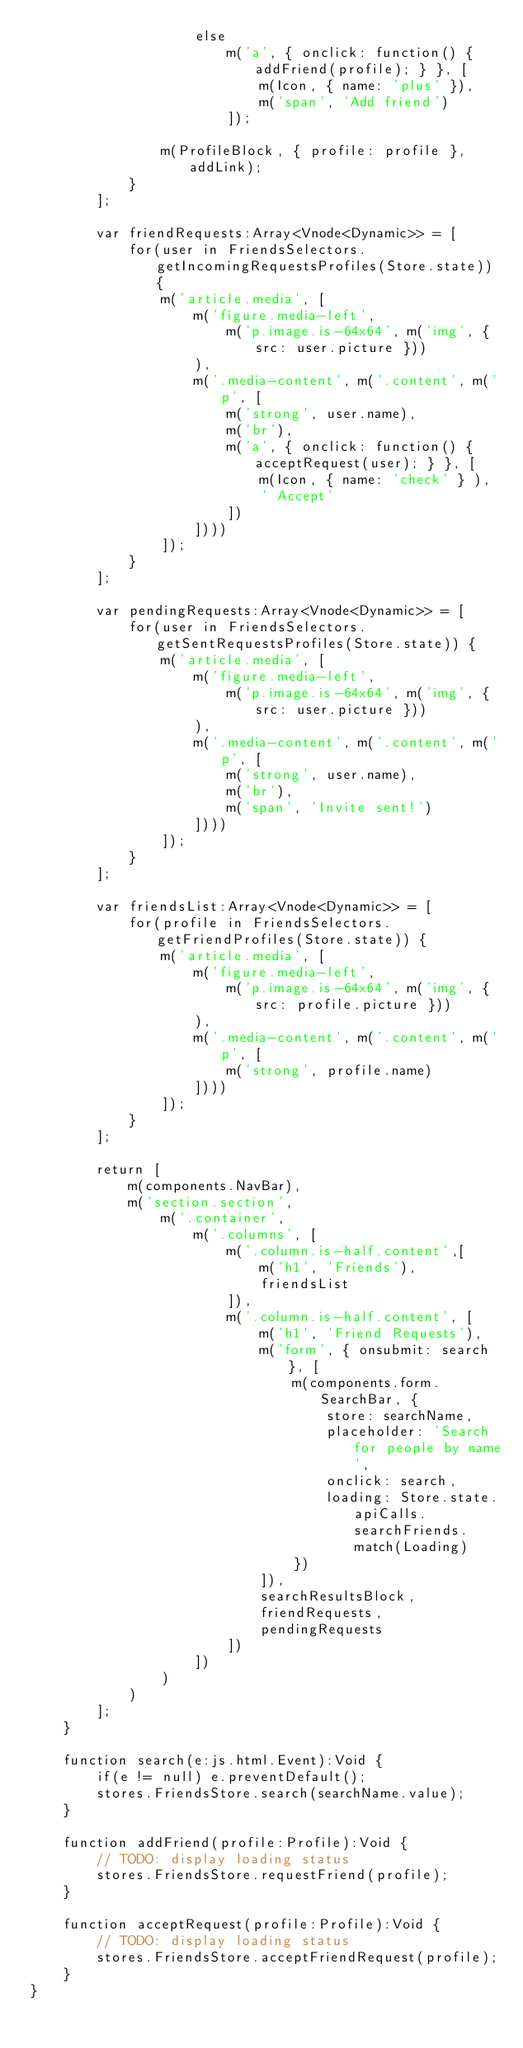Convert code to text. <code><loc_0><loc_0><loc_500><loc_500><_Haxe_>                    else
                        m('a', { onclick: function() { addFriend(profile); } }, [
                            m(Icon, { name: 'plus' }),
                            m('span', 'Add friend')
                        ]);

                m(ProfileBlock, { profile: profile }, addLink);
            }
        ];

        var friendRequests:Array<Vnode<Dynamic>> = [
            for(user in FriendsSelectors.getIncomingRequestsProfiles(Store.state)) {
                m('article.media', [
                    m('figure.media-left',
                        m('p.image.is-64x64', m('img', { src: user.picture }))
                    ),
                    m('.media-content', m('.content', m('p', [
                        m('strong', user.name),
                        m('br'),
                        m('a', { onclick: function() { acceptRequest(user); } }, [
                            m(Icon, { name: 'check' } ),
                            ' Accept'
                        ])
                    ])))
                ]);
            }
        ];

        var pendingRequests:Array<Vnode<Dynamic>> = [
            for(user in FriendsSelectors.getSentRequestsProfiles(Store.state)) {
                m('article.media', [
                    m('figure.media-left',
                        m('p.image.is-64x64', m('img', { src: user.picture }))
                    ),
                    m('.media-content', m('.content', m('p', [
                        m('strong', user.name),
                        m('br'),
                        m('span', 'Invite sent!')
                    ])))
                ]);
            }
        ];

        var friendsList:Array<Vnode<Dynamic>> = [
            for(profile in FriendsSelectors.getFriendProfiles(Store.state)) {
                m('article.media', [
                    m('figure.media-left',
                        m('p.image.is-64x64', m('img', { src: profile.picture }))
                    ),
                    m('.media-content', m('.content', m('p', [
                        m('strong', profile.name)
                    ])))
                ]);
            }
        ];

        return [
            m(components.NavBar),
            m('section.section',
                m('.container',
                    m('.columns', [
                        m('.column.is-half.content',[
                            m('h1', 'Friends'),
                            friendsList
                        ]),
                        m('.column.is-half.content', [
                            m('h1', 'Friend Requests'),
                            m('form', { onsubmit: search }, [
                                m(components.form.SearchBar, {
                                    store: searchName,
                                    placeholder: 'Search for people by name',
                                    onclick: search,
                                    loading: Store.state.apiCalls.searchFriends.match(Loading)
                                })
                            ]),
                            searchResultsBlock,
                            friendRequests,
                            pendingRequests
                        ])
                    ])
                )
            )
        ];
    }

    function search(e:js.html.Event):Void {
        if(e != null) e.preventDefault();
        stores.FriendsStore.search(searchName.value);
    }

    function addFriend(profile:Profile):Void {
        // TODO: display loading status
        stores.FriendsStore.requestFriend(profile);
    }

    function acceptRequest(profile:Profile):Void {
        // TODO: display loading status
        stores.FriendsStore.acceptFriendRequest(profile);
    }
}</code> 